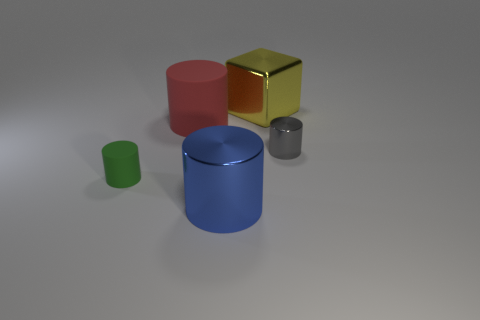Subtract 1 cylinders. How many cylinders are left? 3 Add 4 large blue shiny cylinders. How many objects exist? 9 Subtract all cylinders. How many objects are left? 1 Add 1 tiny blue balls. How many tiny blue balls exist? 1 Subtract 0 brown balls. How many objects are left? 5 Subtract all large metallic things. Subtract all large green metallic spheres. How many objects are left? 3 Add 4 tiny green cylinders. How many tiny green cylinders are left? 5 